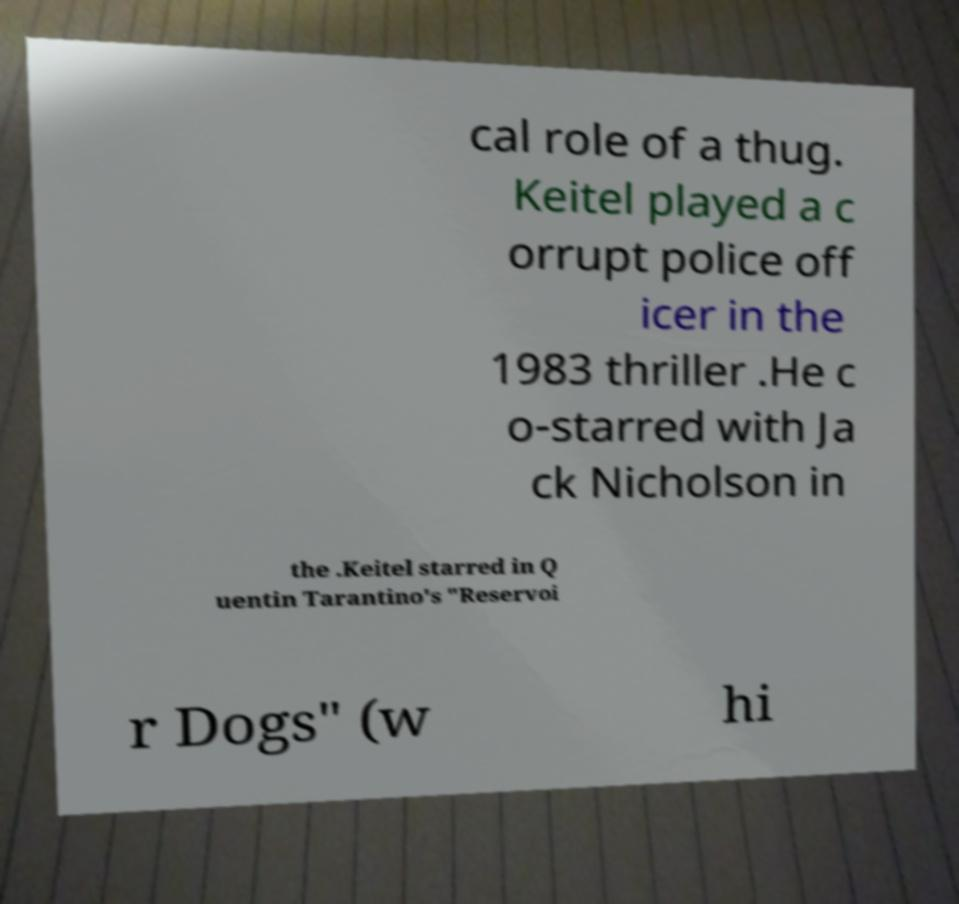Please identify and transcribe the text found in this image. cal role of a thug. Keitel played a c orrupt police off icer in the 1983 thriller .He c o-starred with Ja ck Nicholson in the .Keitel starred in Q uentin Tarantino's "Reservoi r Dogs" (w hi 